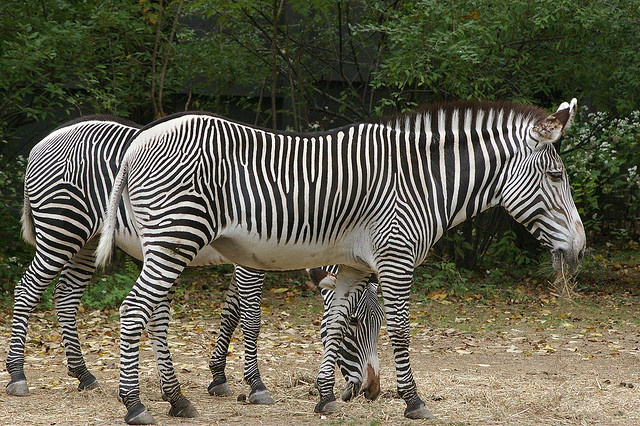Describe the objects in this image and their specific colors. I can see zebra in darkgreen, black, lightgray, darkgray, and gray tones and zebra in darkgreen, black, gray, white, and darkgray tones in this image. 